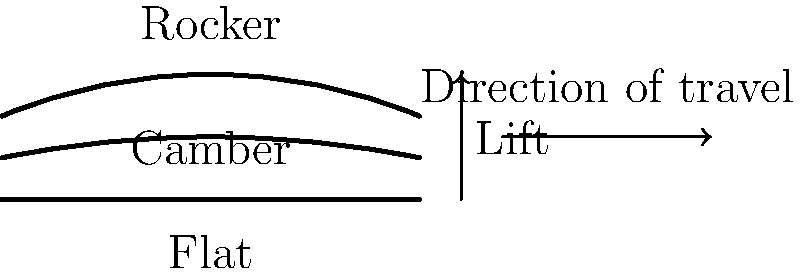Which snowboard profile typically provides the most lift and maneuverability in powder conditions, and why? To answer this question, let's examine the three common snowboard profiles shown in the illustration:

1. Flat: The bottom edge of the board is completely straight.
2. Camber: The board has an upward arch in the middle when unweighted.
3. Rocker (also called reverse camber): The board has a downward arch in the middle, with the nose and tail raised.

The rocker profile typically provides the most lift and maneuverability in powder conditions for the following reasons:

1. Increased flotation: The upturned nose and tail of the rocker profile help the board stay on top of deep snow more easily. This reduces the effort required to keep the board's nose above the snow surface.

2. Reduced edge contact: The rocker shape means less of the board's edge is in contact with the snow when riding flat. This makes it easier to initiate turns and pivot the board in deep snow.

3. Improved maneuverability: The reduced edge contact and lifted nose and tail make it easier to shift your weight and change direction quickly in powder.

4. Better powder distribution: The curved shape helps to displace snow more efficiently, pushing it to the sides rather than compressing it directly underneath the board.

5. Reduced risk of "nose diving": The lifted nose is less likely to catch and dive under the snow surface, which can cause sudden stops or falls.

While camber profiles excel in providing edge hold and pop on groomed runs, and flat profiles offer a balance between the two, the rocker profile is specifically advantageous in powder conditions due to its shape and how it interacts with deep, soft snow.
Answer: Rocker profile, due to increased flotation and maneuverability in deep snow. 